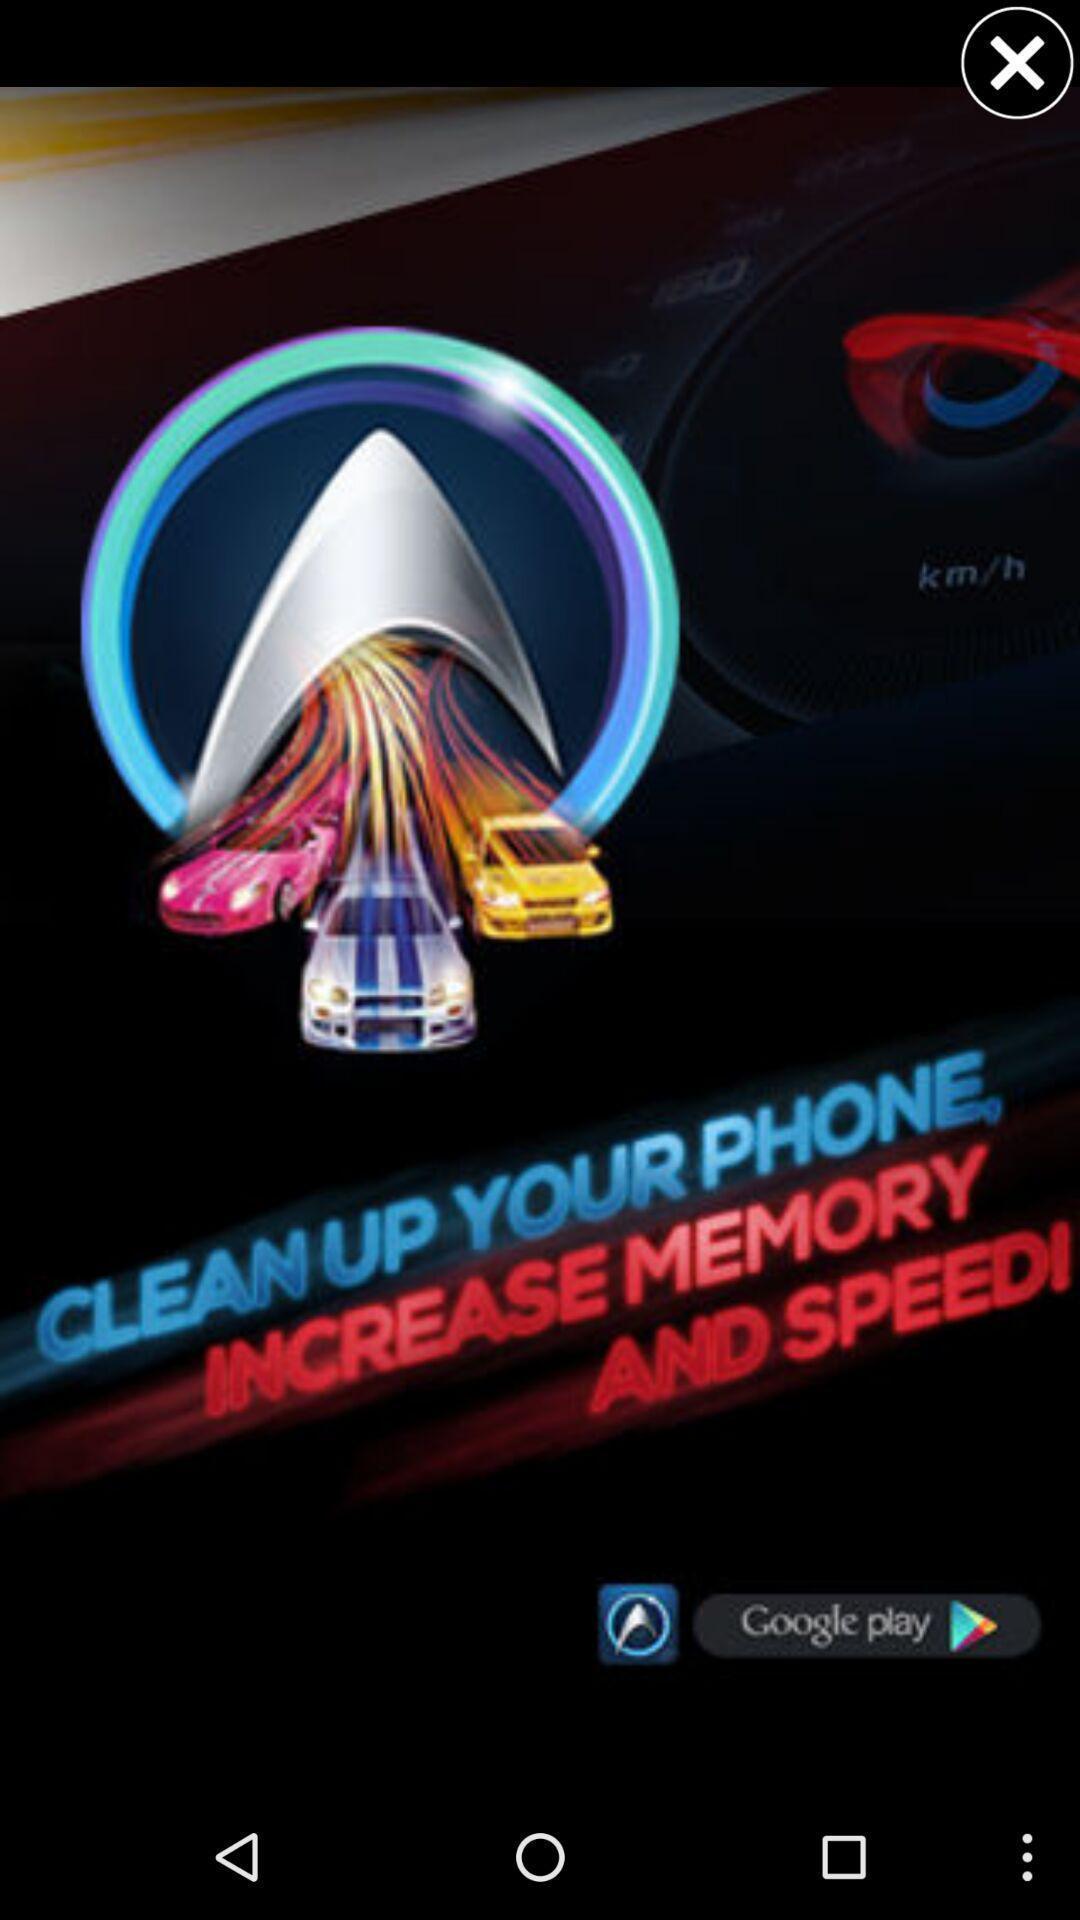Explain what's happening in this screen capture. Pop up showing an advertisement on an app. 